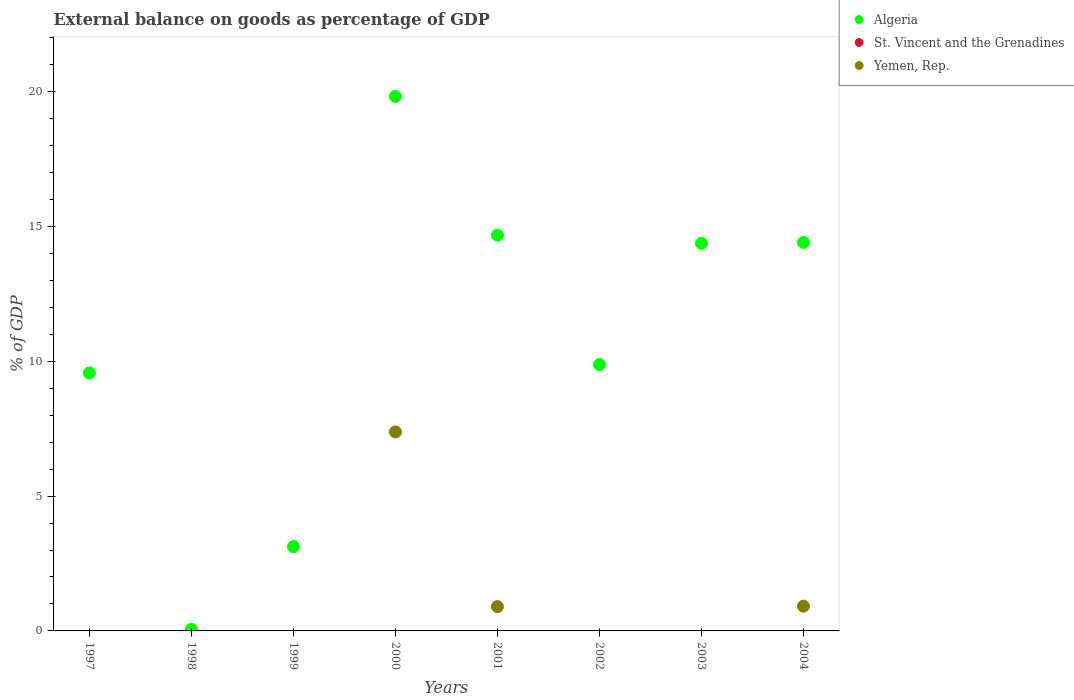How many different coloured dotlines are there?
Give a very brief answer. 2. Is the number of dotlines equal to the number of legend labels?
Your answer should be very brief. No. Across all years, what is the maximum external balance on goods as percentage of GDP in Yemen, Rep.?
Make the answer very short. 7.38. Across all years, what is the minimum external balance on goods as percentage of GDP in Algeria?
Your answer should be compact. 0.06. What is the total external balance on goods as percentage of GDP in Algeria in the graph?
Your answer should be compact. 85.9. What is the difference between the external balance on goods as percentage of GDP in Algeria in 2002 and that in 2003?
Offer a very short reply. -4.5. What is the difference between the external balance on goods as percentage of GDP in St. Vincent and the Grenadines in 1998 and the external balance on goods as percentage of GDP in Algeria in 2003?
Your answer should be very brief. -14.37. What is the average external balance on goods as percentage of GDP in St. Vincent and the Grenadines per year?
Your answer should be very brief. 0. In how many years, is the external balance on goods as percentage of GDP in St. Vincent and the Grenadines greater than 20 %?
Keep it short and to the point. 0. What is the ratio of the external balance on goods as percentage of GDP in Yemen, Rep. in 2000 to that in 2004?
Your answer should be very brief. 8.04. What is the difference between the highest and the second highest external balance on goods as percentage of GDP in Yemen, Rep.?
Offer a very short reply. 6.46. What is the difference between the highest and the lowest external balance on goods as percentage of GDP in Algeria?
Give a very brief answer. 19.76. In how many years, is the external balance on goods as percentage of GDP in Yemen, Rep. greater than the average external balance on goods as percentage of GDP in Yemen, Rep. taken over all years?
Provide a succinct answer. 1. Does the external balance on goods as percentage of GDP in Algeria monotonically increase over the years?
Ensure brevity in your answer.  No. Is the external balance on goods as percentage of GDP in Algeria strictly greater than the external balance on goods as percentage of GDP in St. Vincent and the Grenadines over the years?
Your answer should be compact. Yes. How many dotlines are there?
Your response must be concise. 2. What is the difference between two consecutive major ticks on the Y-axis?
Your answer should be very brief. 5. Are the values on the major ticks of Y-axis written in scientific E-notation?
Your answer should be very brief. No. Does the graph contain grids?
Make the answer very short. No. Where does the legend appear in the graph?
Give a very brief answer. Top right. How are the legend labels stacked?
Your answer should be very brief. Vertical. What is the title of the graph?
Ensure brevity in your answer.  External balance on goods as percentage of GDP. What is the label or title of the X-axis?
Offer a terse response. Years. What is the label or title of the Y-axis?
Make the answer very short. % of GDP. What is the % of GDP in Algeria in 1997?
Provide a succinct answer. 9.57. What is the % of GDP in St. Vincent and the Grenadines in 1997?
Offer a very short reply. 0. What is the % of GDP of Yemen, Rep. in 1997?
Ensure brevity in your answer.  0. What is the % of GDP of Algeria in 1998?
Ensure brevity in your answer.  0.06. What is the % of GDP in Yemen, Rep. in 1998?
Provide a succinct answer. 0. What is the % of GDP of Algeria in 1999?
Your response must be concise. 3.12. What is the % of GDP of St. Vincent and the Grenadines in 1999?
Ensure brevity in your answer.  0. What is the % of GDP in Algeria in 2000?
Your response must be concise. 19.82. What is the % of GDP of Yemen, Rep. in 2000?
Your answer should be very brief. 7.38. What is the % of GDP of Algeria in 2001?
Ensure brevity in your answer.  14.67. What is the % of GDP of St. Vincent and the Grenadines in 2001?
Provide a succinct answer. 0. What is the % of GDP of Yemen, Rep. in 2001?
Your answer should be very brief. 0.9. What is the % of GDP of Algeria in 2002?
Your answer should be compact. 9.87. What is the % of GDP of Yemen, Rep. in 2002?
Offer a very short reply. 0. What is the % of GDP of Algeria in 2003?
Make the answer very short. 14.37. What is the % of GDP in St. Vincent and the Grenadines in 2003?
Your answer should be compact. 0. What is the % of GDP in Yemen, Rep. in 2003?
Your answer should be very brief. 0. What is the % of GDP of Algeria in 2004?
Ensure brevity in your answer.  14.41. What is the % of GDP in St. Vincent and the Grenadines in 2004?
Ensure brevity in your answer.  0. What is the % of GDP of Yemen, Rep. in 2004?
Provide a short and direct response. 0.92. Across all years, what is the maximum % of GDP in Algeria?
Provide a succinct answer. 19.82. Across all years, what is the maximum % of GDP in Yemen, Rep.?
Your answer should be compact. 7.38. Across all years, what is the minimum % of GDP in Algeria?
Provide a short and direct response. 0.06. What is the total % of GDP of Algeria in the graph?
Give a very brief answer. 85.9. What is the total % of GDP in St. Vincent and the Grenadines in the graph?
Give a very brief answer. 0. What is the total % of GDP in Yemen, Rep. in the graph?
Provide a succinct answer. 9.2. What is the difference between the % of GDP in Algeria in 1997 and that in 1998?
Provide a succinct answer. 9.51. What is the difference between the % of GDP in Algeria in 1997 and that in 1999?
Your response must be concise. 6.44. What is the difference between the % of GDP of Algeria in 1997 and that in 2000?
Provide a succinct answer. -10.25. What is the difference between the % of GDP in Algeria in 1997 and that in 2001?
Provide a succinct answer. -5.1. What is the difference between the % of GDP of Algeria in 1997 and that in 2002?
Your response must be concise. -0.31. What is the difference between the % of GDP of Algeria in 1997 and that in 2003?
Give a very brief answer. -4.8. What is the difference between the % of GDP of Algeria in 1997 and that in 2004?
Your answer should be very brief. -4.84. What is the difference between the % of GDP in Algeria in 1998 and that in 1999?
Offer a terse response. -3.06. What is the difference between the % of GDP of Algeria in 1998 and that in 2000?
Your answer should be very brief. -19.76. What is the difference between the % of GDP in Algeria in 1998 and that in 2001?
Ensure brevity in your answer.  -14.61. What is the difference between the % of GDP of Algeria in 1998 and that in 2002?
Make the answer very short. -9.81. What is the difference between the % of GDP of Algeria in 1998 and that in 2003?
Your answer should be compact. -14.31. What is the difference between the % of GDP of Algeria in 1998 and that in 2004?
Offer a terse response. -14.34. What is the difference between the % of GDP of Algeria in 1999 and that in 2000?
Your answer should be compact. -16.7. What is the difference between the % of GDP in Algeria in 1999 and that in 2001?
Ensure brevity in your answer.  -11.55. What is the difference between the % of GDP of Algeria in 1999 and that in 2002?
Provide a succinct answer. -6.75. What is the difference between the % of GDP in Algeria in 1999 and that in 2003?
Ensure brevity in your answer.  -11.25. What is the difference between the % of GDP in Algeria in 1999 and that in 2004?
Offer a very short reply. -11.28. What is the difference between the % of GDP in Algeria in 2000 and that in 2001?
Your response must be concise. 5.15. What is the difference between the % of GDP of Yemen, Rep. in 2000 and that in 2001?
Offer a very short reply. 6.48. What is the difference between the % of GDP of Algeria in 2000 and that in 2002?
Give a very brief answer. 9.95. What is the difference between the % of GDP of Algeria in 2000 and that in 2003?
Give a very brief answer. 5.45. What is the difference between the % of GDP in Algeria in 2000 and that in 2004?
Your response must be concise. 5.42. What is the difference between the % of GDP in Yemen, Rep. in 2000 and that in 2004?
Give a very brief answer. 6.46. What is the difference between the % of GDP of Algeria in 2001 and that in 2002?
Ensure brevity in your answer.  4.8. What is the difference between the % of GDP in Algeria in 2001 and that in 2003?
Ensure brevity in your answer.  0.3. What is the difference between the % of GDP in Algeria in 2001 and that in 2004?
Offer a terse response. 0.27. What is the difference between the % of GDP of Yemen, Rep. in 2001 and that in 2004?
Your answer should be compact. -0.02. What is the difference between the % of GDP of Algeria in 2002 and that in 2003?
Ensure brevity in your answer.  -4.5. What is the difference between the % of GDP of Algeria in 2002 and that in 2004?
Your response must be concise. -4.53. What is the difference between the % of GDP of Algeria in 2003 and that in 2004?
Your answer should be very brief. -0.03. What is the difference between the % of GDP of Algeria in 1997 and the % of GDP of Yemen, Rep. in 2000?
Keep it short and to the point. 2.19. What is the difference between the % of GDP of Algeria in 1997 and the % of GDP of Yemen, Rep. in 2001?
Provide a short and direct response. 8.67. What is the difference between the % of GDP in Algeria in 1997 and the % of GDP in Yemen, Rep. in 2004?
Offer a terse response. 8.65. What is the difference between the % of GDP in Algeria in 1998 and the % of GDP in Yemen, Rep. in 2000?
Keep it short and to the point. -7.32. What is the difference between the % of GDP in Algeria in 1998 and the % of GDP in Yemen, Rep. in 2001?
Offer a very short reply. -0.84. What is the difference between the % of GDP in Algeria in 1998 and the % of GDP in Yemen, Rep. in 2004?
Offer a terse response. -0.86. What is the difference between the % of GDP of Algeria in 1999 and the % of GDP of Yemen, Rep. in 2000?
Provide a succinct answer. -4.25. What is the difference between the % of GDP in Algeria in 1999 and the % of GDP in Yemen, Rep. in 2001?
Offer a very short reply. 2.22. What is the difference between the % of GDP in Algeria in 1999 and the % of GDP in Yemen, Rep. in 2004?
Your answer should be compact. 2.21. What is the difference between the % of GDP of Algeria in 2000 and the % of GDP of Yemen, Rep. in 2001?
Give a very brief answer. 18.92. What is the difference between the % of GDP in Algeria in 2000 and the % of GDP in Yemen, Rep. in 2004?
Provide a succinct answer. 18.9. What is the difference between the % of GDP in Algeria in 2001 and the % of GDP in Yemen, Rep. in 2004?
Give a very brief answer. 13.75. What is the difference between the % of GDP in Algeria in 2002 and the % of GDP in Yemen, Rep. in 2004?
Provide a short and direct response. 8.96. What is the difference between the % of GDP in Algeria in 2003 and the % of GDP in Yemen, Rep. in 2004?
Ensure brevity in your answer.  13.45. What is the average % of GDP in Algeria per year?
Keep it short and to the point. 10.74. What is the average % of GDP of Yemen, Rep. per year?
Ensure brevity in your answer.  1.15. In the year 2000, what is the difference between the % of GDP of Algeria and % of GDP of Yemen, Rep.?
Make the answer very short. 12.44. In the year 2001, what is the difference between the % of GDP in Algeria and % of GDP in Yemen, Rep.?
Your answer should be very brief. 13.77. In the year 2004, what is the difference between the % of GDP of Algeria and % of GDP of Yemen, Rep.?
Your answer should be compact. 13.49. What is the ratio of the % of GDP in Algeria in 1997 to that in 1998?
Give a very brief answer. 153.7. What is the ratio of the % of GDP of Algeria in 1997 to that in 1999?
Keep it short and to the point. 3.06. What is the ratio of the % of GDP in Algeria in 1997 to that in 2000?
Offer a terse response. 0.48. What is the ratio of the % of GDP of Algeria in 1997 to that in 2001?
Your answer should be compact. 0.65. What is the ratio of the % of GDP in Algeria in 1997 to that in 2002?
Your response must be concise. 0.97. What is the ratio of the % of GDP in Algeria in 1997 to that in 2003?
Offer a terse response. 0.67. What is the ratio of the % of GDP in Algeria in 1997 to that in 2004?
Your response must be concise. 0.66. What is the ratio of the % of GDP of Algeria in 1998 to that in 1999?
Your response must be concise. 0.02. What is the ratio of the % of GDP of Algeria in 1998 to that in 2000?
Offer a very short reply. 0. What is the ratio of the % of GDP of Algeria in 1998 to that in 2001?
Provide a succinct answer. 0. What is the ratio of the % of GDP in Algeria in 1998 to that in 2002?
Provide a succinct answer. 0.01. What is the ratio of the % of GDP of Algeria in 1998 to that in 2003?
Give a very brief answer. 0. What is the ratio of the % of GDP of Algeria in 1998 to that in 2004?
Offer a very short reply. 0. What is the ratio of the % of GDP in Algeria in 1999 to that in 2000?
Provide a succinct answer. 0.16. What is the ratio of the % of GDP in Algeria in 1999 to that in 2001?
Make the answer very short. 0.21. What is the ratio of the % of GDP in Algeria in 1999 to that in 2002?
Your answer should be compact. 0.32. What is the ratio of the % of GDP of Algeria in 1999 to that in 2003?
Offer a terse response. 0.22. What is the ratio of the % of GDP of Algeria in 1999 to that in 2004?
Keep it short and to the point. 0.22. What is the ratio of the % of GDP of Algeria in 2000 to that in 2001?
Your answer should be very brief. 1.35. What is the ratio of the % of GDP in Yemen, Rep. in 2000 to that in 2001?
Give a very brief answer. 8.19. What is the ratio of the % of GDP of Algeria in 2000 to that in 2002?
Your answer should be compact. 2.01. What is the ratio of the % of GDP of Algeria in 2000 to that in 2003?
Provide a short and direct response. 1.38. What is the ratio of the % of GDP in Algeria in 2000 to that in 2004?
Your answer should be very brief. 1.38. What is the ratio of the % of GDP of Yemen, Rep. in 2000 to that in 2004?
Keep it short and to the point. 8.04. What is the ratio of the % of GDP of Algeria in 2001 to that in 2002?
Make the answer very short. 1.49. What is the ratio of the % of GDP in Algeria in 2001 to that in 2003?
Offer a terse response. 1.02. What is the ratio of the % of GDP of Algeria in 2001 to that in 2004?
Offer a terse response. 1.02. What is the ratio of the % of GDP in Yemen, Rep. in 2001 to that in 2004?
Your answer should be compact. 0.98. What is the ratio of the % of GDP of Algeria in 2002 to that in 2003?
Provide a short and direct response. 0.69. What is the ratio of the % of GDP in Algeria in 2002 to that in 2004?
Provide a succinct answer. 0.69. What is the difference between the highest and the second highest % of GDP in Algeria?
Provide a succinct answer. 5.15. What is the difference between the highest and the second highest % of GDP in Yemen, Rep.?
Make the answer very short. 6.46. What is the difference between the highest and the lowest % of GDP of Algeria?
Your answer should be very brief. 19.76. What is the difference between the highest and the lowest % of GDP of Yemen, Rep.?
Provide a succinct answer. 7.38. 